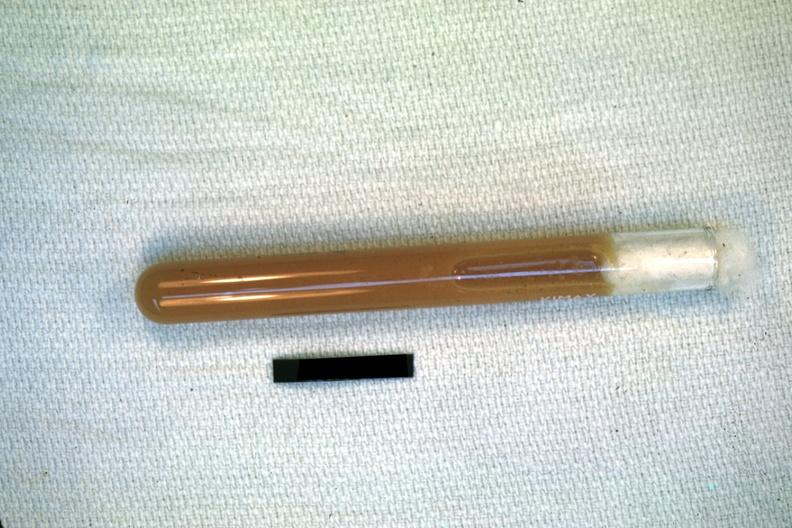s abdomen present?
Answer the question using a single word or phrase. Yes 